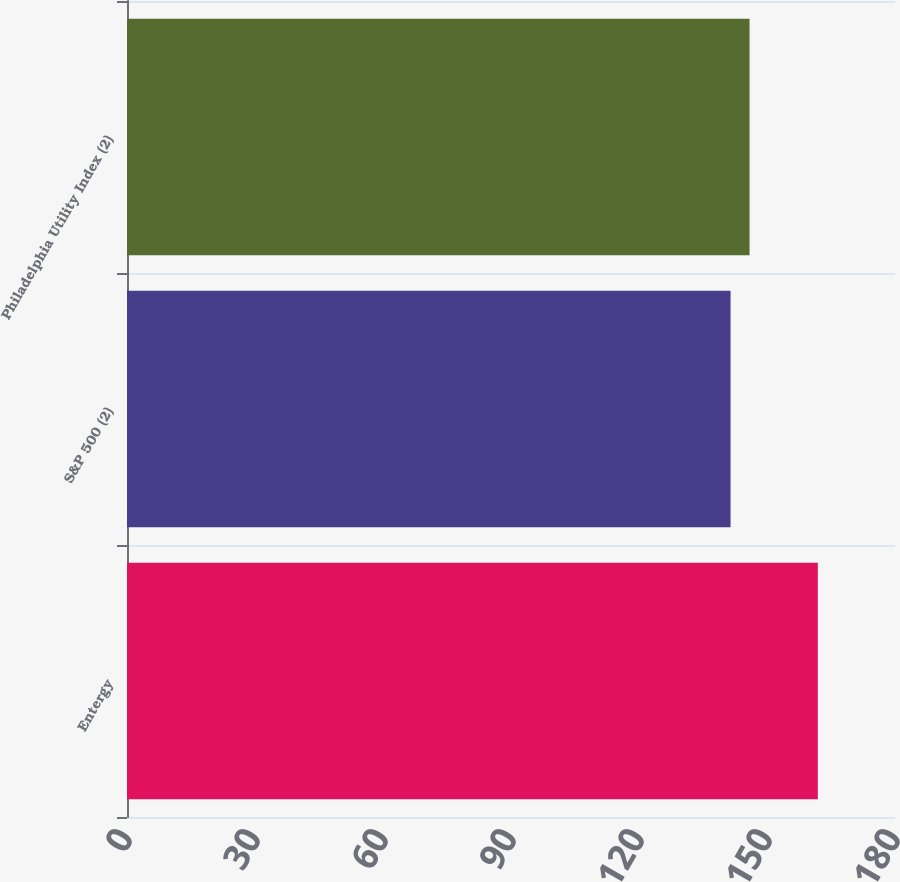Convert chart to OTSL. <chart><loc_0><loc_0><loc_500><loc_500><bar_chart><fcel>Entergy<fcel>S&P 500 (2)<fcel>Philadelphia Utility Index (2)<nl><fcel>161.91<fcel>141.46<fcel>145.91<nl></chart> 